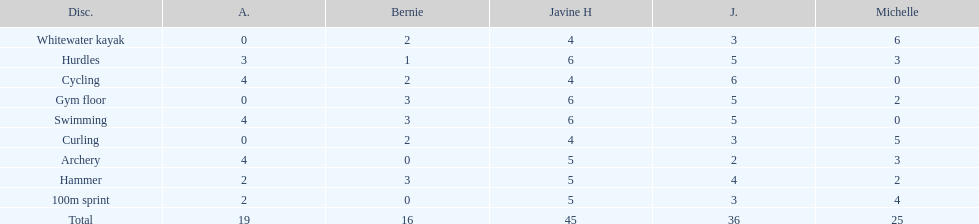What are the number of points bernie scored in hurdles? 1. 